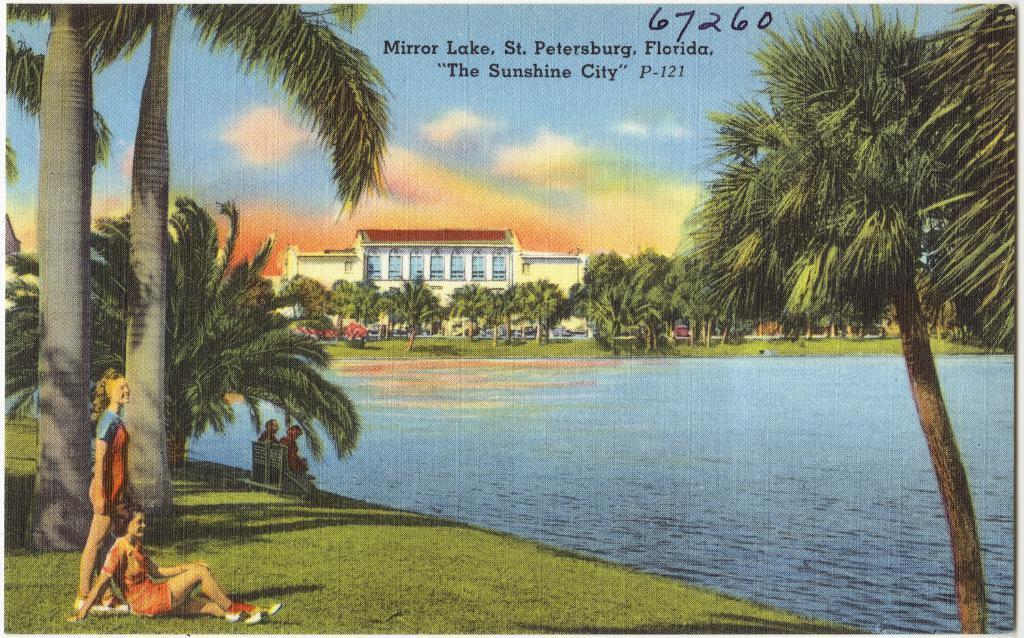Describe this image in one or two sentences. This image is a photograph. In this image there are two woman present on the grass and two people are sitting on the bench and enjoying the river view. In the background there are many trees. Building and a text on the photograph with a number is also visible. There is a sky with clouds. 